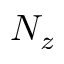<formula> <loc_0><loc_0><loc_500><loc_500>N _ { z }</formula> 